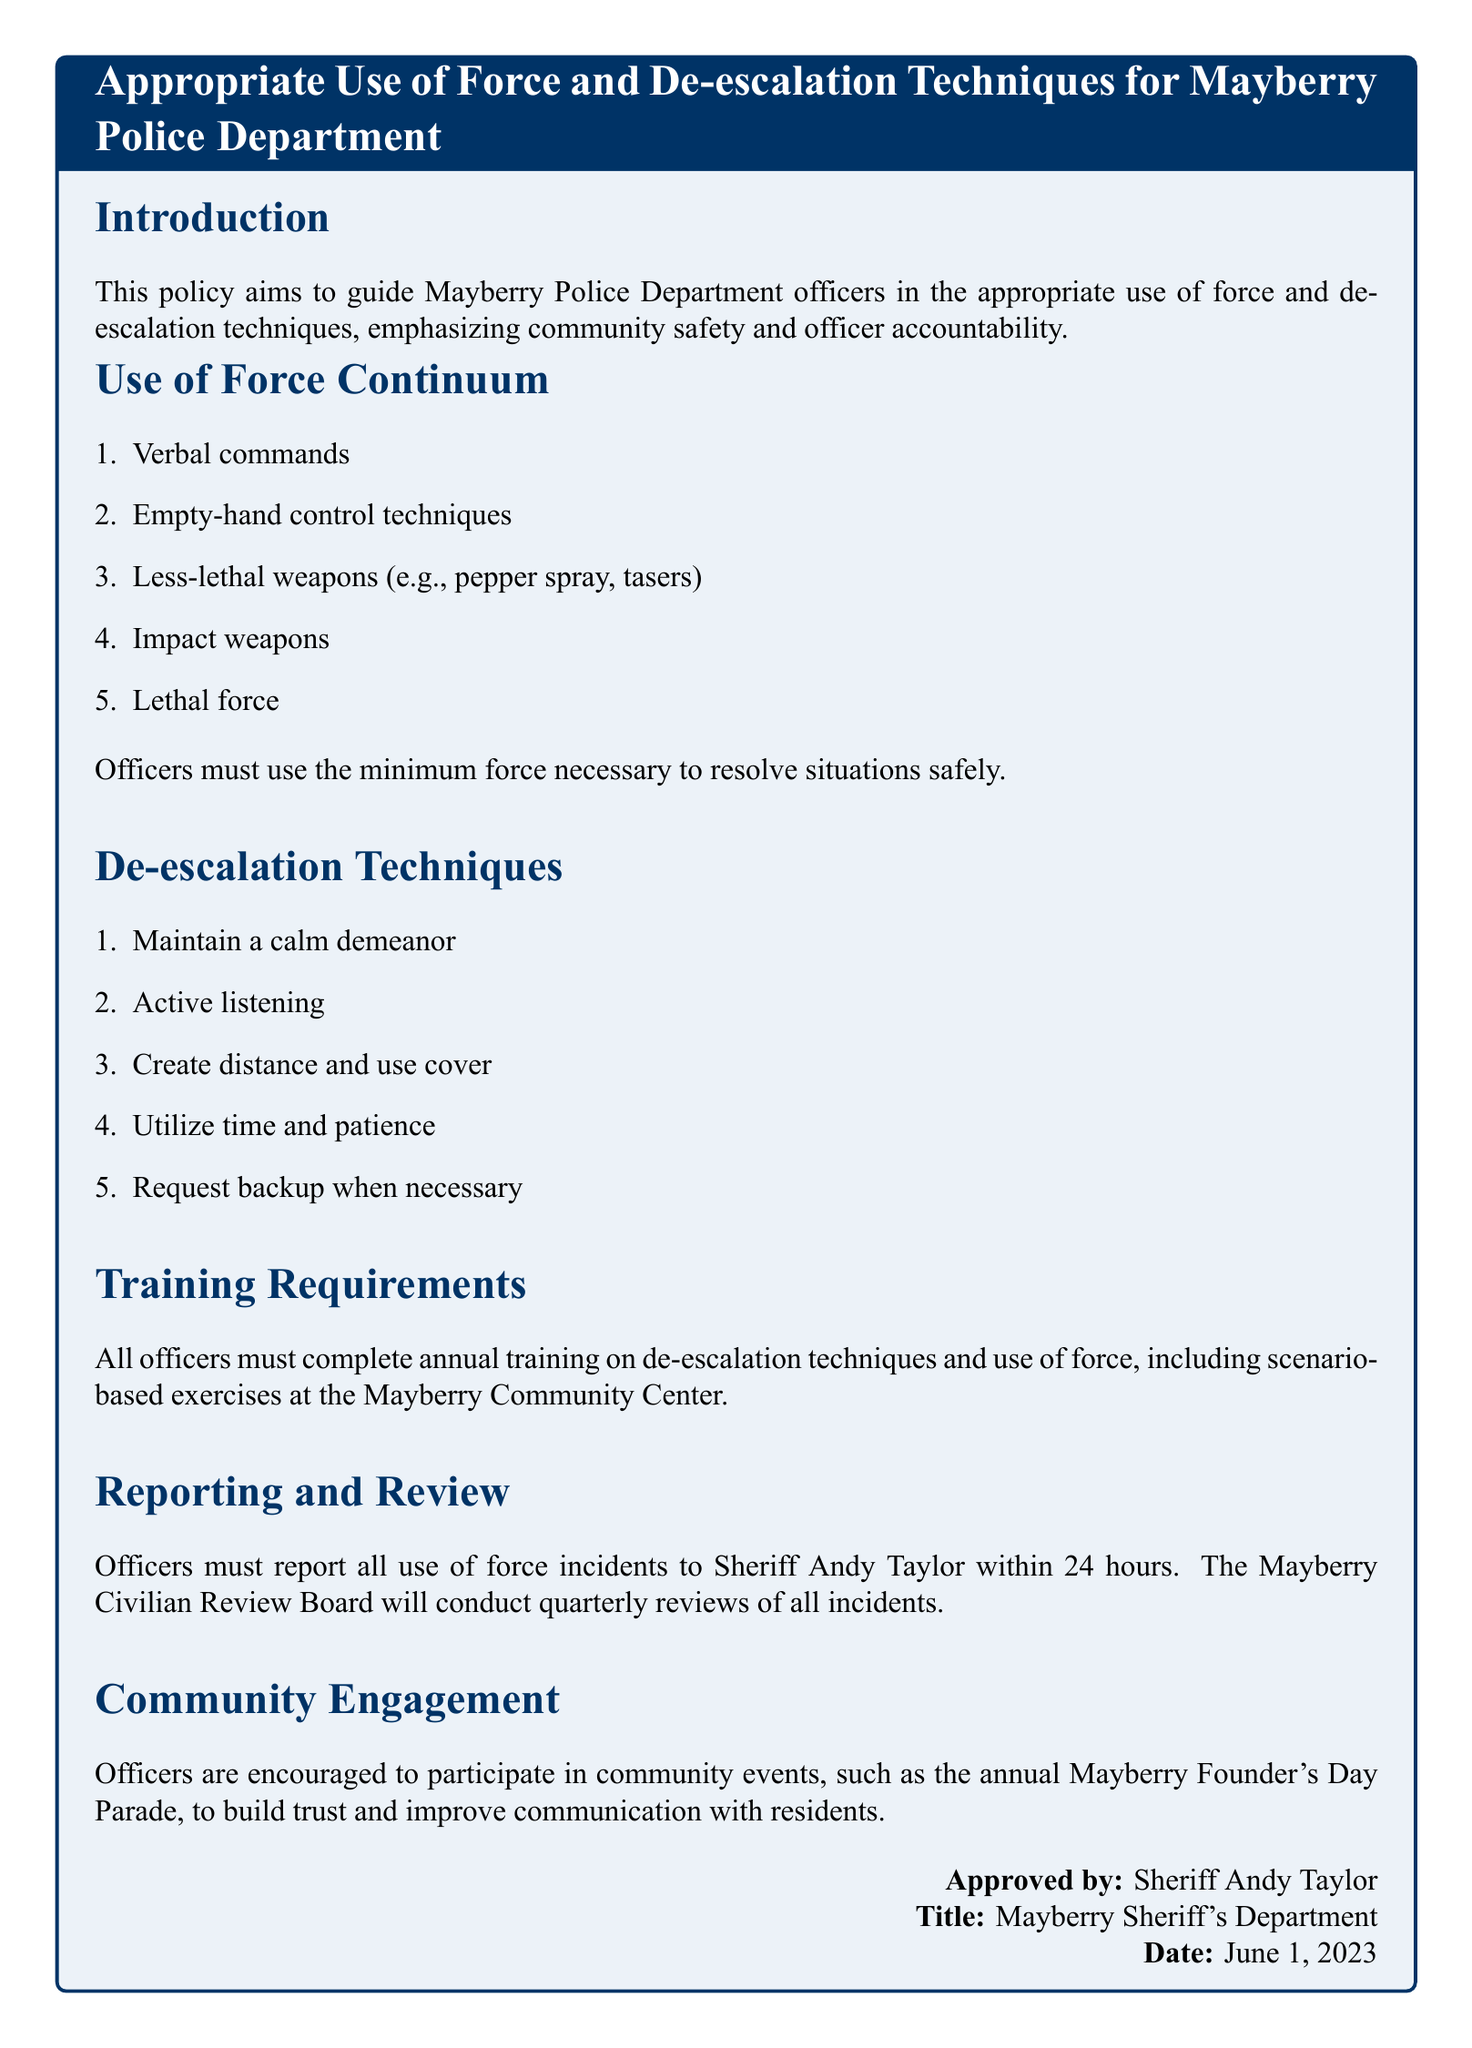What is the title of the policy document? The title is stated at the beginning of the policy document, highlighting the focus on appropriate use of force and de-escalation techniques.
Answer: Appropriate Use of Force and De-escalation Techniques for Mayberry Police Department Who approved the document? The approval section of the document clearly states the name of the individual who authorized the policy.
Answer: Sheriff Andy Taylor How many use of force types are listed in the continuum? The document enumerates different types of force in the use of force continuum, which are clearly numbered for clarity.
Answer: Five What is the minimum time frame for reporting a use of force incident? The reporting section specifies the time limit within which officers need to report incidents.
Answer: 24 hours What training is required for officers? The training requirements section outlines the necessity of completing specific training related to de-escalation techniques and use of force annually.
Answer: Annual training Which community event do officers participate in? The community engagement section mentions a specific event designed for building trust and communication with residents.
Answer: Mayberry Founder's Day Parade What technique involves creating distance? The de-escalation techniques list highlights specific actions that can be taken to safely manage situations, including this particular strategy.
Answer: Create distance and use cover How often does the Civilian Review Board conduct reviews? The document states the frequency of reviews conducted by the designated board concerning use of force incidents.
Answer: Quarterly 